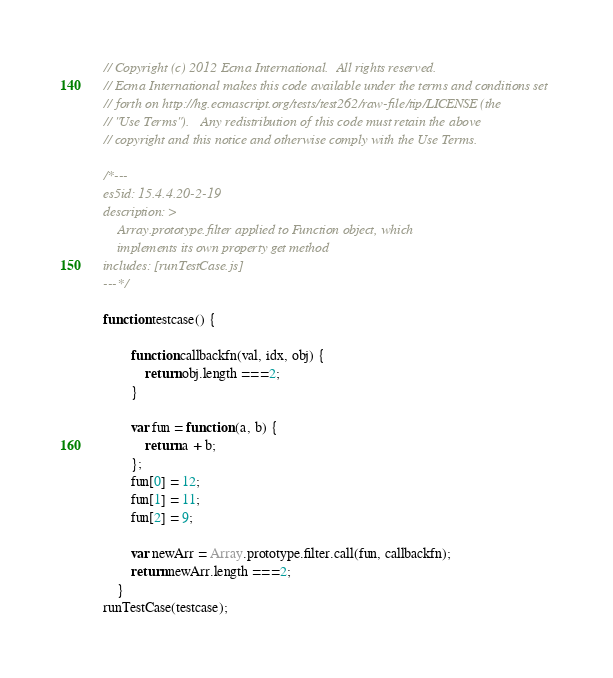<code> <loc_0><loc_0><loc_500><loc_500><_JavaScript_>// Copyright (c) 2012 Ecma International.  All rights reserved.
// Ecma International makes this code available under the terms and conditions set
// forth on http://hg.ecmascript.org/tests/test262/raw-file/tip/LICENSE (the
// "Use Terms").   Any redistribution of this code must retain the above
// copyright and this notice and otherwise comply with the Use Terms.

/*---
es5id: 15.4.4.20-2-19
description: >
    Array.prototype.filter applied to Function object, which
    implements its own property get method
includes: [runTestCase.js]
---*/

function testcase() {

        function callbackfn(val, idx, obj) {
            return obj.length === 2;
        }

        var fun = function (a, b) {
            return a + b;
        };
        fun[0] = 12;
        fun[1] = 11;
        fun[2] = 9;

        var newArr = Array.prototype.filter.call(fun, callbackfn);
        return newArr.length === 2;
    }
runTestCase(testcase);
</code> 